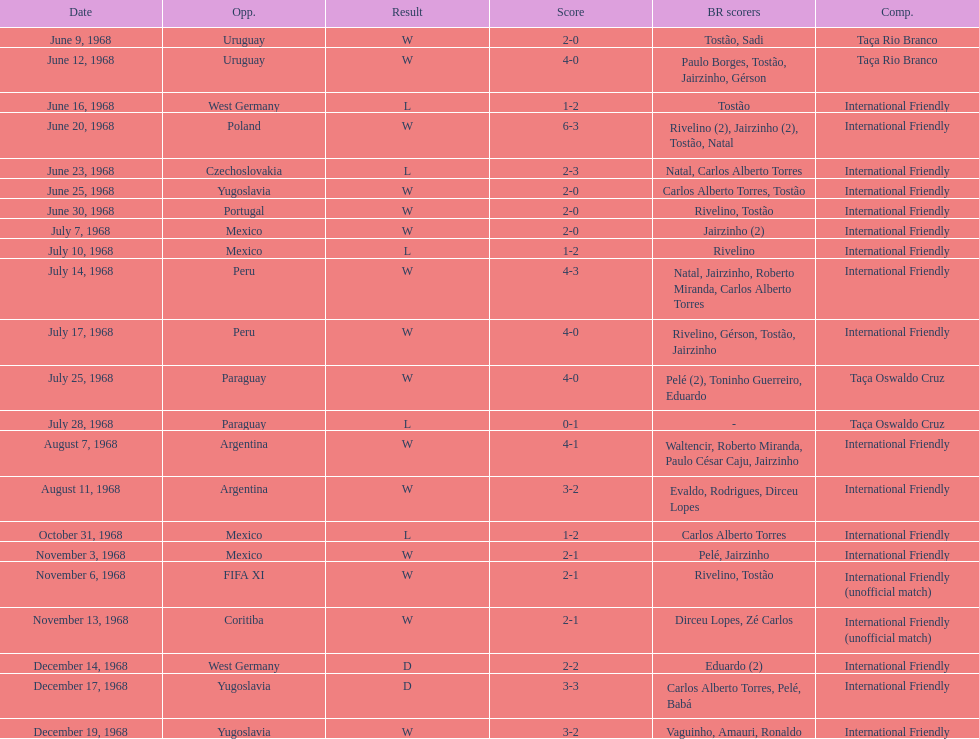How many times did brazil score during the game on november 6th? 2. 